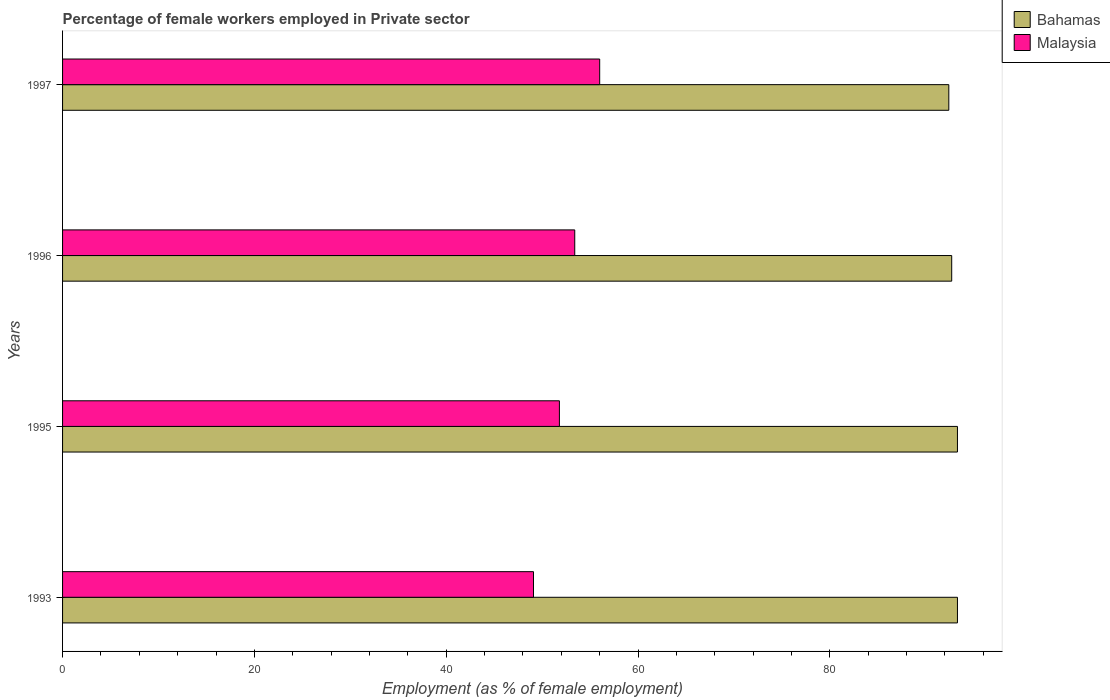Are the number of bars on each tick of the Y-axis equal?
Your answer should be compact. Yes. What is the label of the 4th group of bars from the top?
Provide a succinct answer. 1993. What is the percentage of females employed in Private sector in Malaysia in 1996?
Provide a short and direct response. 53.4. Across all years, what is the maximum percentage of females employed in Private sector in Malaysia?
Offer a very short reply. 56. Across all years, what is the minimum percentage of females employed in Private sector in Malaysia?
Your answer should be compact. 49.1. In which year was the percentage of females employed in Private sector in Bahamas minimum?
Provide a short and direct response. 1997. What is the total percentage of females employed in Private sector in Bahamas in the graph?
Offer a terse response. 371.7. What is the difference between the percentage of females employed in Private sector in Malaysia in 1993 and that in 1997?
Make the answer very short. -6.9. What is the difference between the percentage of females employed in Private sector in Malaysia in 1993 and the percentage of females employed in Private sector in Bahamas in 1995?
Offer a very short reply. -44.2. What is the average percentage of females employed in Private sector in Malaysia per year?
Offer a terse response. 52.57. In the year 1995, what is the difference between the percentage of females employed in Private sector in Bahamas and percentage of females employed in Private sector in Malaysia?
Offer a terse response. 41.5. In how many years, is the percentage of females employed in Private sector in Malaysia greater than 84 %?
Provide a short and direct response. 0. What is the ratio of the percentage of females employed in Private sector in Bahamas in 1993 to that in 1997?
Keep it short and to the point. 1.01. Is the percentage of females employed in Private sector in Malaysia in 1995 less than that in 1996?
Your answer should be very brief. Yes. Is the difference between the percentage of females employed in Private sector in Bahamas in 1993 and 1995 greater than the difference between the percentage of females employed in Private sector in Malaysia in 1993 and 1995?
Your answer should be very brief. Yes. What is the difference between the highest and the lowest percentage of females employed in Private sector in Malaysia?
Your answer should be compact. 6.9. Is the sum of the percentage of females employed in Private sector in Bahamas in 1993 and 1996 greater than the maximum percentage of females employed in Private sector in Malaysia across all years?
Ensure brevity in your answer.  Yes. What does the 2nd bar from the top in 1993 represents?
Your response must be concise. Bahamas. What does the 2nd bar from the bottom in 1997 represents?
Your answer should be compact. Malaysia. Are all the bars in the graph horizontal?
Offer a very short reply. Yes. Are the values on the major ticks of X-axis written in scientific E-notation?
Ensure brevity in your answer.  No. Does the graph contain grids?
Keep it short and to the point. No. How many legend labels are there?
Provide a succinct answer. 2. How are the legend labels stacked?
Provide a succinct answer. Vertical. What is the title of the graph?
Offer a very short reply. Percentage of female workers employed in Private sector. What is the label or title of the X-axis?
Offer a very short reply. Employment (as % of female employment). What is the Employment (as % of female employment) in Bahamas in 1993?
Offer a very short reply. 93.3. What is the Employment (as % of female employment) of Malaysia in 1993?
Make the answer very short. 49.1. What is the Employment (as % of female employment) of Bahamas in 1995?
Your answer should be very brief. 93.3. What is the Employment (as % of female employment) of Malaysia in 1995?
Give a very brief answer. 51.8. What is the Employment (as % of female employment) of Bahamas in 1996?
Make the answer very short. 92.7. What is the Employment (as % of female employment) in Malaysia in 1996?
Offer a very short reply. 53.4. What is the Employment (as % of female employment) in Bahamas in 1997?
Your response must be concise. 92.4. What is the Employment (as % of female employment) in Malaysia in 1997?
Offer a very short reply. 56. Across all years, what is the maximum Employment (as % of female employment) in Bahamas?
Give a very brief answer. 93.3. Across all years, what is the minimum Employment (as % of female employment) of Bahamas?
Make the answer very short. 92.4. Across all years, what is the minimum Employment (as % of female employment) of Malaysia?
Offer a very short reply. 49.1. What is the total Employment (as % of female employment) of Bahamas in the graph?
Provide a short and direct response. 371.7. What is the total Employment (as % of female employment) of Malaysia in the graph?
Offer a terse response. 210.3. What is the difference between the Employment (as % of female employment) in Bahamas in 1993 and that in 1995?
Make the answer very short. 0. What is the difference between the Employment (as % of female employment) in Bahamas in 1993 and that in 1996?
Ensure brevity in your answer.  0.6. What is the difference between the Employment (as % of female employment) in Malaysia in 1993 and that in 1996?
Provide a succinct answer. -4.3. What is the difference between the Employment (as % of female employment) of Bahamas in 1993 and that in 1997?
Make the answer very short. 0.9. What is the difference between the Employment (as % of female employment) of Bahamas in 1995 and that in 1996?
Provide a short and direct response. 0.6. What is the difference between the Employment (as % of female employment) of Malaysia in 1995 and that in 1997?
Make the answer very short. -4.2. What is the difference between the Employment (as % of female employment) of Bahamas in 1996 and that in 1997?
Your answer should be compact. 0.3. What is the difference between the Employment (as % of female employment) in Bahamas in 1993 and the Employment (as % of female employment) in Malaysia in 1995?
Your answer should be compact. 41.5. What is the difference between the Employment (as % of female employment) of Bahamas in 1993 and the Employment (as % of female employment) of Malaysia in 1996?
Ensure brevity in your answer.  39.9. What is the difference between the Employment (as % of female employment) in Bahamas in 1993 and the Employment (as % of female employment) in Malaysia in 1997?
Provide a succinct answer. 37.3. What is the difference between the Employment (as % of female employment) of Bahamas in 1995 and the Employment (as % of female employment) of Malaysia in 1996?
Offer a very short reply. 39.9. What is the difference between the Employment (as % of female employment) in Bahamas in 1995 and the Employment (as % of female employment) in Malaysia in 1997?
Make the answer very short. 37.3. What is the difference between the Employment (as % of female employment) in Bahamas in 1996 and the Employment (as % of female employment) in Malaysia in 1997?
Keep it short and to the point. 36.7. What is the average Employment (as % of female employment) in Bahamas per year?
Your response must be concise. 92.92. What is the average Employment (as % of female employment) of Malaysia per year?
Your answer should be compact. 52.58. In the year 1993, what is the difference between the Employment (as % of female employment) in Bahamas and Employment (as % of female employment) in Malaysia?
Give a very brief answer. 44.2. In the year 1995, what is the difference between the Employment (as % of female employment) of Bahamas and Employment (as % of female employment) of Malaysia?
Your answer should be compact. 41.5. In the year 1996, what is the difference between the Employment (as % of female employment) in Bahamas and Employment (as % of female employment) in Malaysia?
Your answer should be very brief. 39.3. In the year 1997, what is the difference between the Employment (as % of female employment) of Bahamas and Employment (as % of female employment) of Malaysia?
Offer a very short reply. 36.4. What is the ratio of the Employment (as % of female employment) in Bahamas in 1993 to that in 1995?
Ensure brevity in your answer.  1. What is the ratio of the Employment (as % of female employment) in Malaysia in 1993 to that in 1995?
Your answer should be compact. 0.95. What is the ratio of the Employment (as % of female employment) of Malaysia in 1993 to that in 1996?
Your answer should be compact. 0.92. What is the ratio of the Employment (as % of female employment) in Bahamas in 1993 to that in 1997?
Provide a short and direct response. 1.01. What is the ratio of the Employment (as % of female employment) in Malaysia in 1993 to that in 1997?
Provide a short and direct response. 0.88. What is the ratio of the Employment (as % of female employment) of Bahamas in 1995 to that in 1997?
Your answer should be compact. 1.01. What is the ratio of the Employment (as % of female employment) in Malaysia in 1995 to that in 1997?
Ensure brevity in your answer.  0.93. What is the ratio of the Employment (as % of female employment) of Bahamas in 1996 to that in 1997?
Make the answer very short. 1. What is the ratio of the Employment (as % of female employment) in Malaysia in 1996 to that in 1997?
Your answer should be very brief. 0.95. What is the difference between the highest and the second highest Employment (as % of female employment) in Bahamas?
Give a very brief answer. 0. What is the difference between the highest and the lowest Employment (as % of female employment) in Bahamas?
Offer a very short reply. 0.9. What is the difference between the highest and the lowest Employment (as % of female employment) of Malaysia?
Keep it short and to the point. 6.9. 